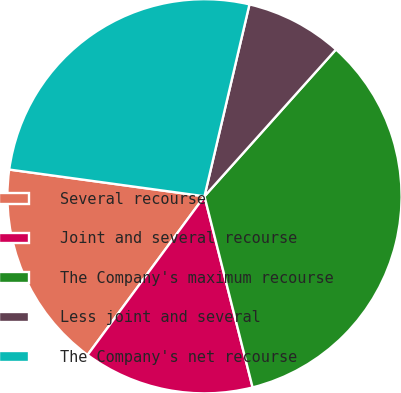Convert chart. <chart><loc_0><loc_0><loc_500><loc_500><pie_chart><fcel>Several recourse<fcel>Joint and several recourse<fcel>The Company's maximum recourse<fcel>Less joint and several<fcel>The Company's net recourse<nl><fcel>17.06%<fcel>14.03%<fcel>34.45%<fcel>7.96%<fcel>26.5%<nl></chart> 